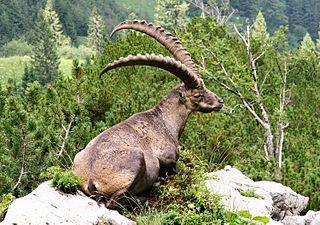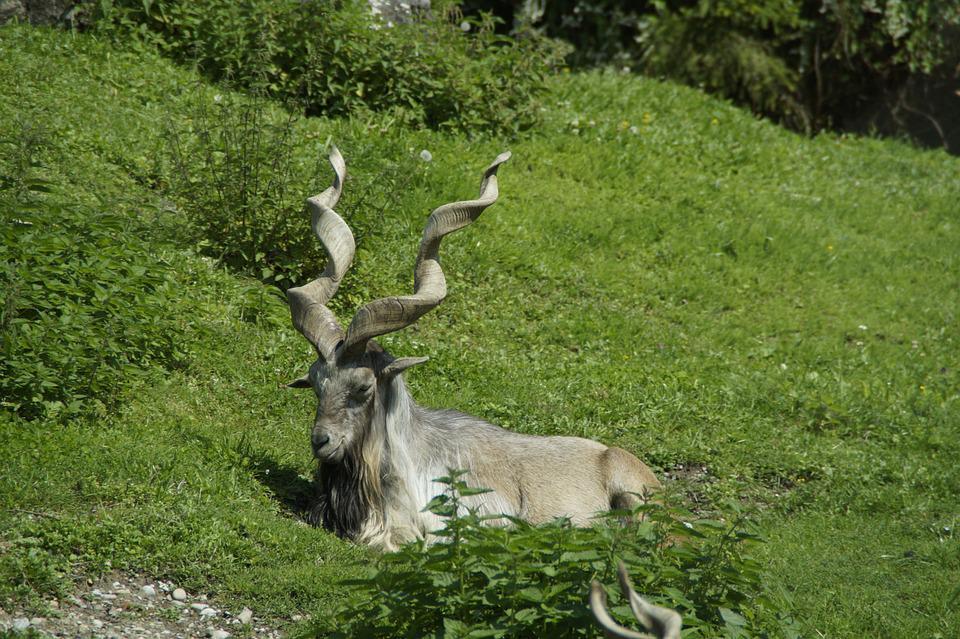The first image is the image on the left, the second image is the image on the right. For the images shown, is this caption "An animal sits atop a rocky outcropping in the image on the right." true? Answer yes or no. No. 